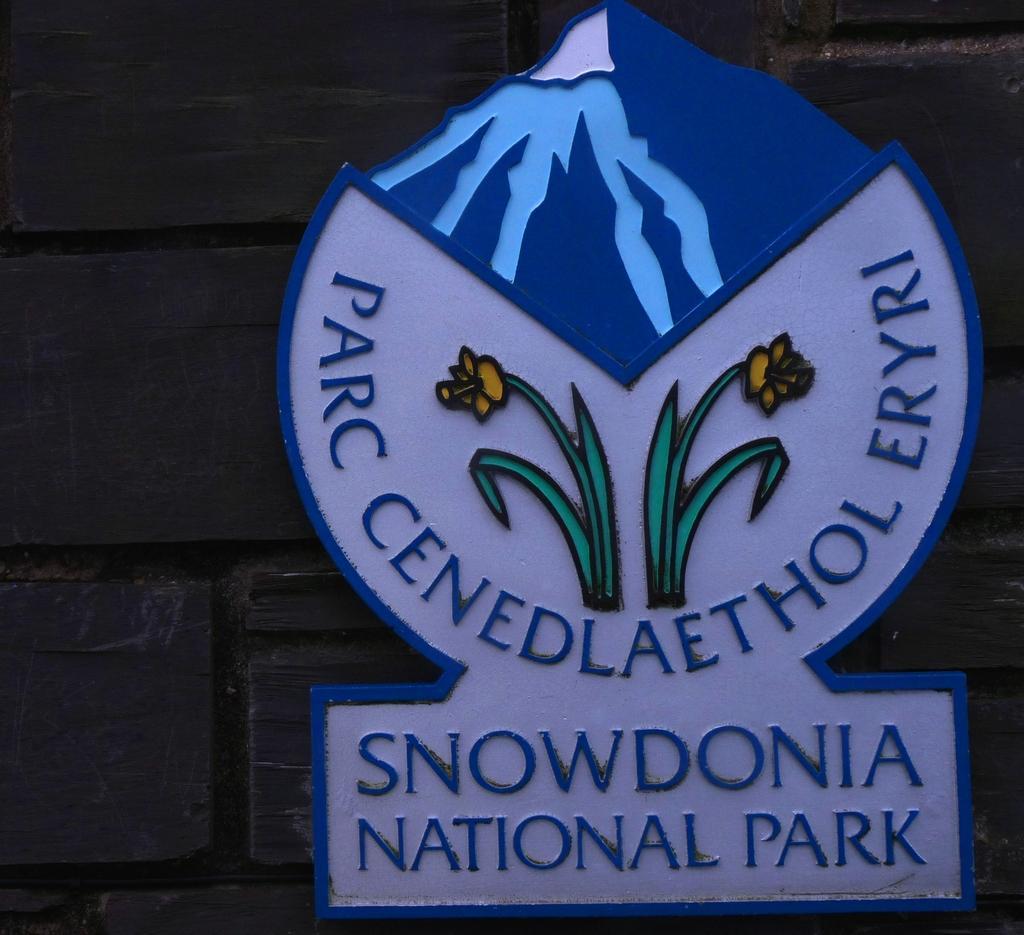Describe this image in one or two sentences. In this image we can see the board with text and image attached to the wall. 